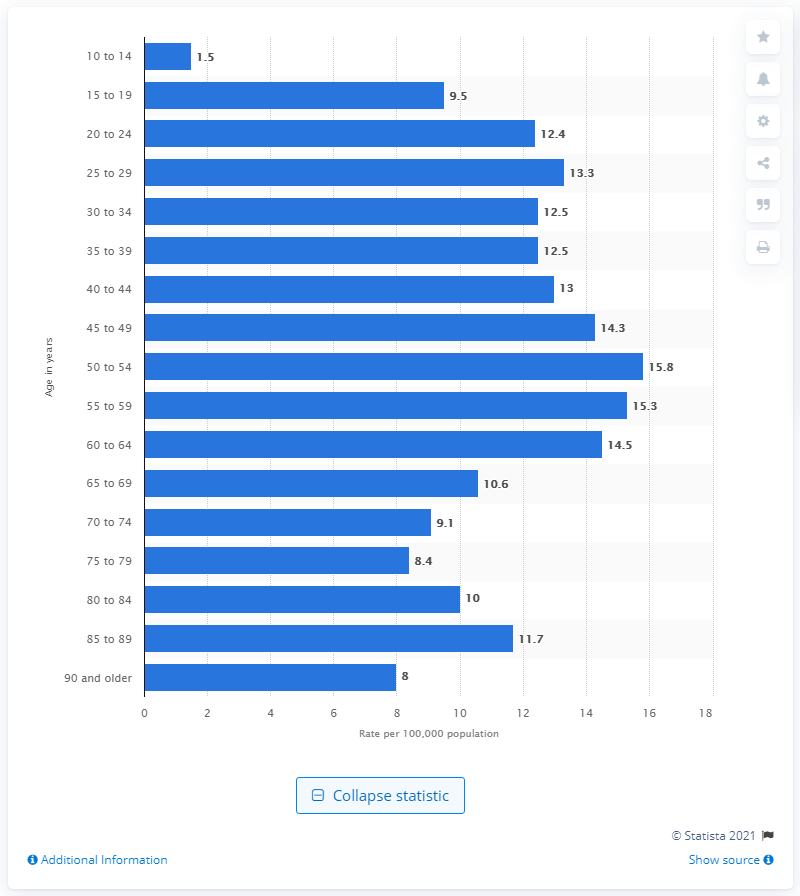Mention a couple of crucial points in this snapshot. In 2019, the suicide rate among 20-24 year olds in Canada was 12.4 per 100,000 individuals. 